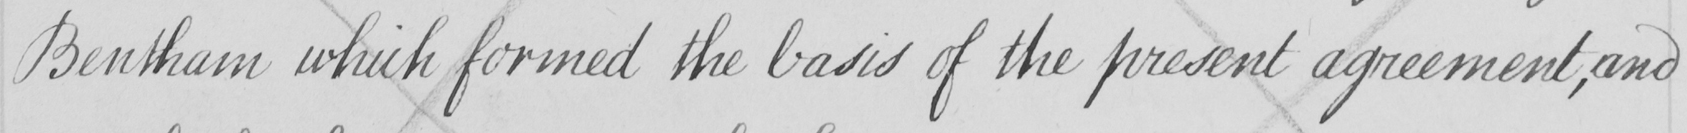Transcribe the text shown in this historical manuscript line. Bentham which formed the basis of the present agreement , and 